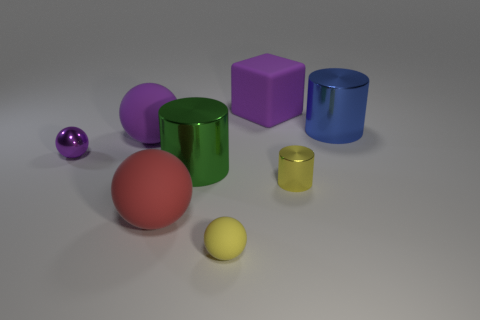What number of other objects are the same size as the shiny sphere?
Provide a succinct answer. 2. How many other things are the same color as the big rubber cube?
Offer a very short reply. 2. What number of other things are there of the same shape as the green metal thing?
Ensure brevity in your answer.  2. Do the purple metallic object and the blue thing have the same size?
Ensure brevity in your answer.  No. Is there a big matte block?
Your answer should be compact. Yes. Are there any tiny purple objects made of the same material as the large red thing?
Your answer should be compact. No. There is a purple thing that is the same size as the purple matte cube; what is it made of?
Give a very brief answer. Rubber. What number of purple metal things have the same shape as the large green metallic thing?
Give a very brief answer. 0. What is the size of the purple ball that is the same material as the yellow cylinder?
Keep it short and to the point. Small. There is a large thing that is both to the left of the green shiny cylinder and behind the green metallic object; what material is it?
Your answer should be compact. Rubber. 